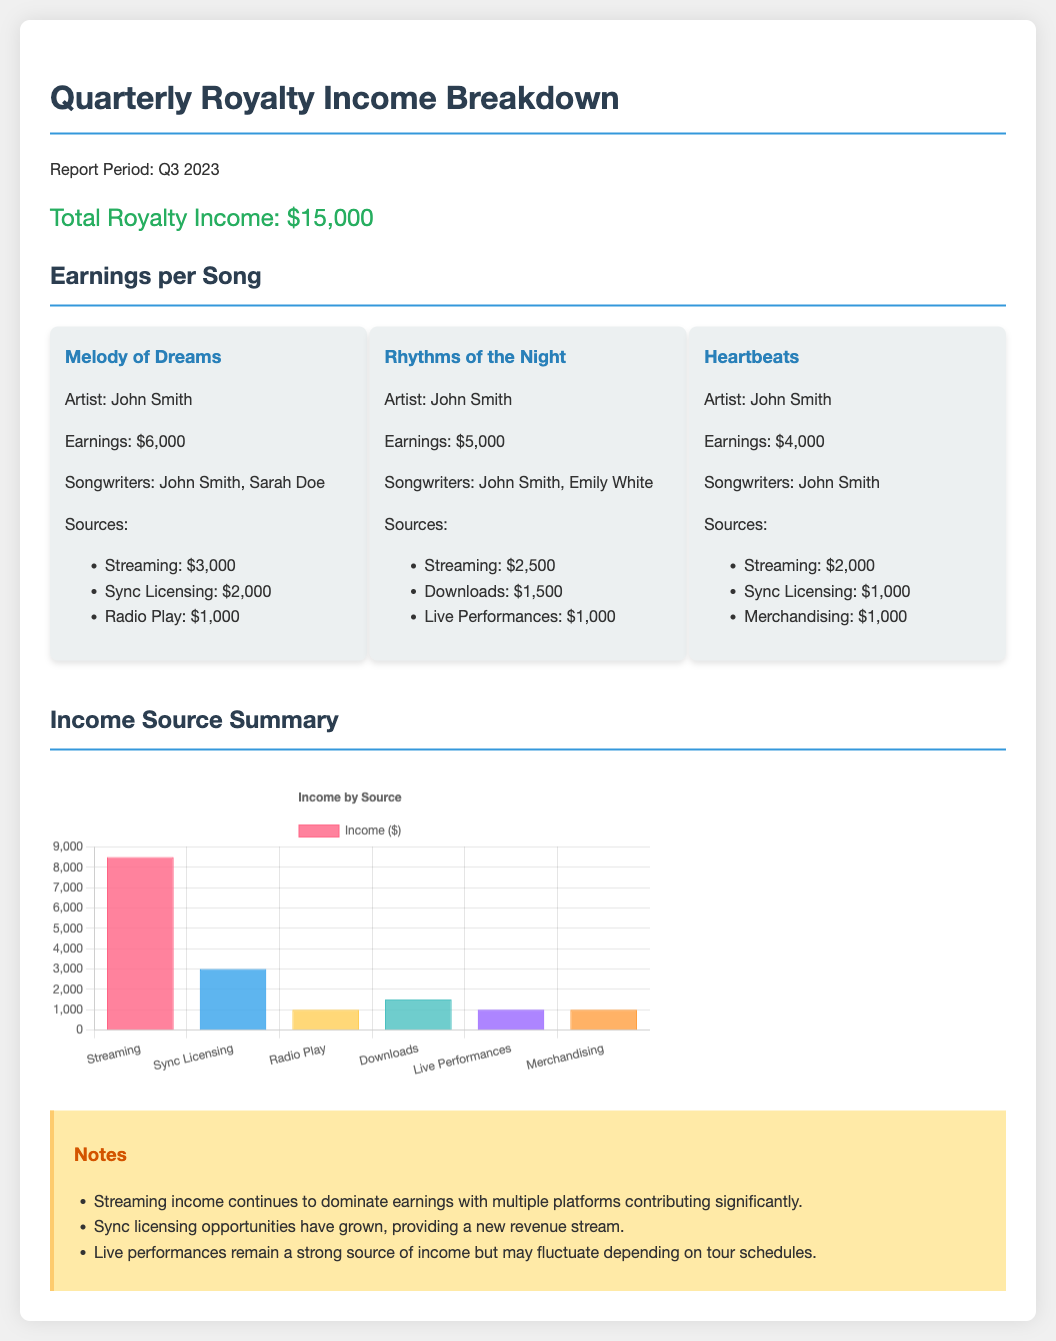What was the total royalty income for Q3 2023? The total royalty income is stated as $15,000.
Answer: $15,000 How much did the song "Melody of Dreams" earn? The document indicates that "Melody of Dreams" earned $6,000.
Answer: $6,000 What is the primary source of income for the song "Rhythms of the Night"? "Rhythms of the Night" generated its highest income from streaming, which was $2,500.
Answer: Streaming How many songwriters are credited for "Heartbeats"? The song "Heartbeats" lists one songwriter, John Smith.
Answer: One What is the combined total earnings from streaming sources for all songs? The total from streaming sources is calculated as $3,000 + $2,500 + $2,000 = $7,500.
Answer: $7,500 Which song earned the least amount of money? "Heartbeats" earned the least among the listed songs with $4,000.
Answer: Heartbeats What additional source contributed to "Melody of Dreams" earnings apart from streaming? Besides streaming, "Melody of Dreams" also earned from sync licensing, contributing $2,000.
Answer: Sync Licensing How much income did live performances generate? The income from live performances is specified as $1,000.
Answer: $1,000 What does the notes section highlight about sync licensing? The notes mention that sync licensing opportunities have grown, indicating increased revenue potential.
Answer: Revenue stream 